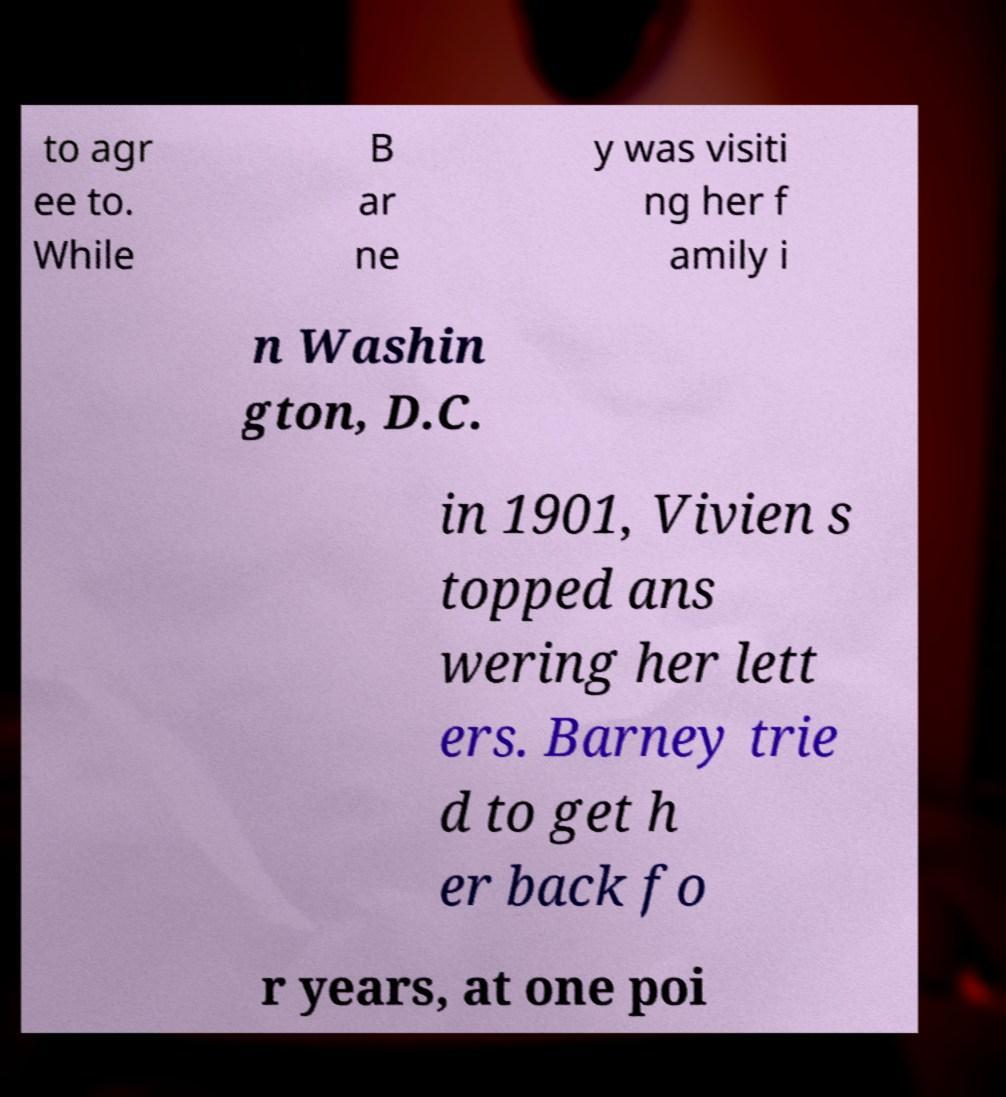There's text embedded in this image that I need extracted. Can you transcribe it verbatim? to agr ee to. While B ar ne y was visiti ng her f amily i n Washin gton, D.C. in 1901, Vivien s topped ans wering her lett ers. Barney trie d to get h er back fo r years, at one poi 